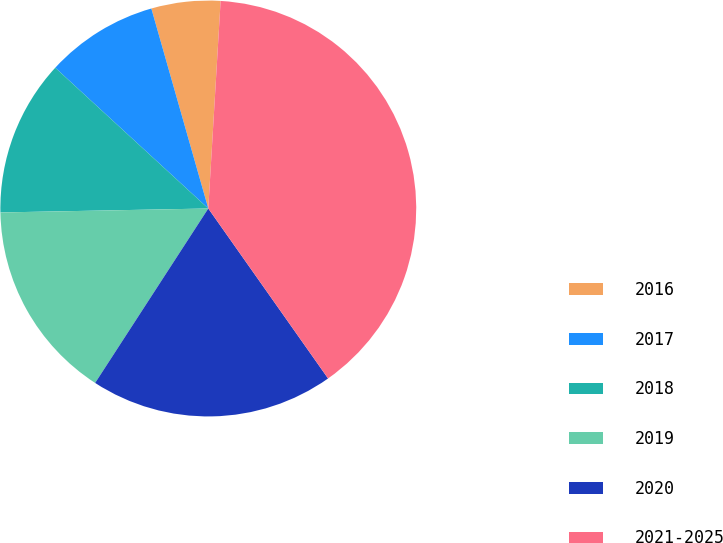Convert chart to OTSL. <chart><loc_0><loc_0><loc_500><loc_500><pie_chart><fcel>2016<fcel>2017<fcel>2018<fcel>2019<fcel>2020<fcel>2021-2025<nl><fcel>5.36%<fcel>8.75%<fcel>12.14%<fcel>15.54%<fcel>18.93%<fcel>39.29%<nl></chart> 